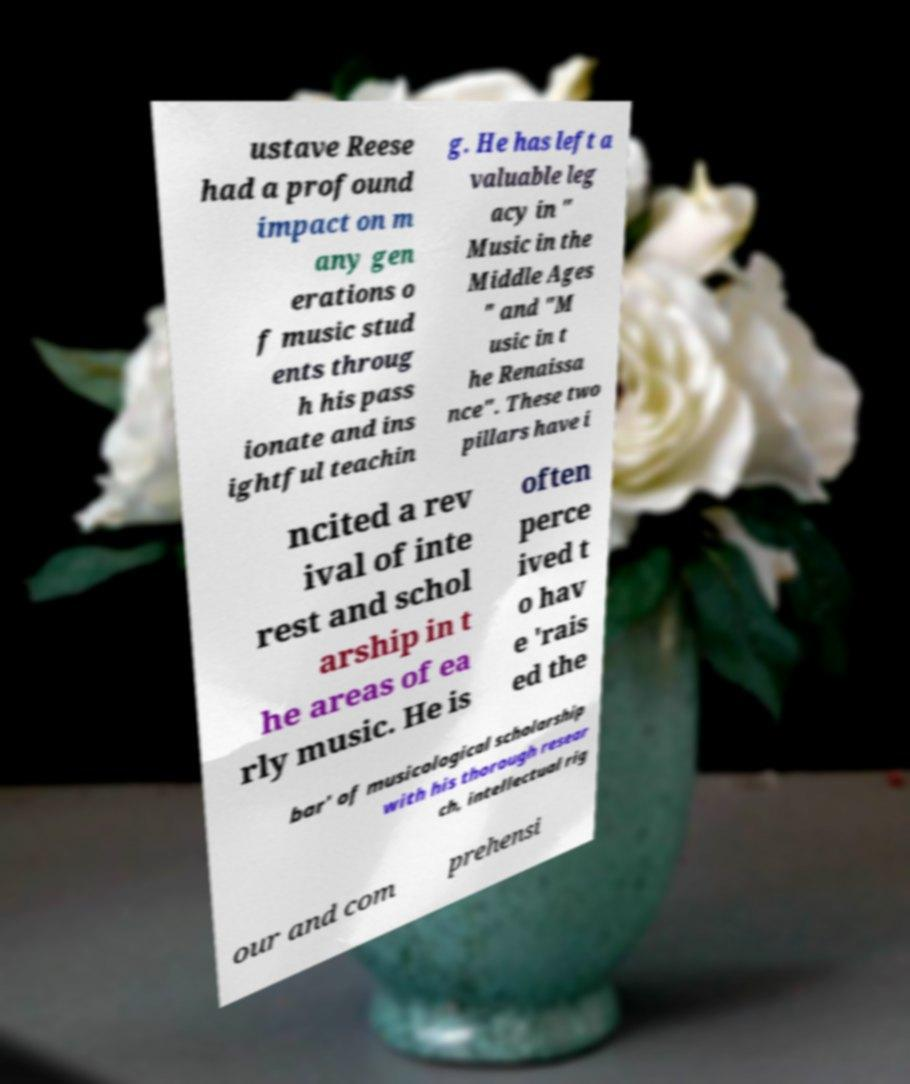What messages or text are displayed in this image? I need them in a readable, typed format. ustave Reese had a profound impact on m any gen erations o f music stud ents throug h his pass ionate and ins ightful teachin g. He has left a valuable leg acy in " Music in the Middle Ages " and "M usic in t he Renaissa nce". These two pillars have i ncited a rev ival of inte rest and schol arship in t he areas of ea rly music. He is often perce ived t o hav e 'rais ed the bar' of musicological scholarship with his thorough resear ch, intellectual rig our and com prehensi 